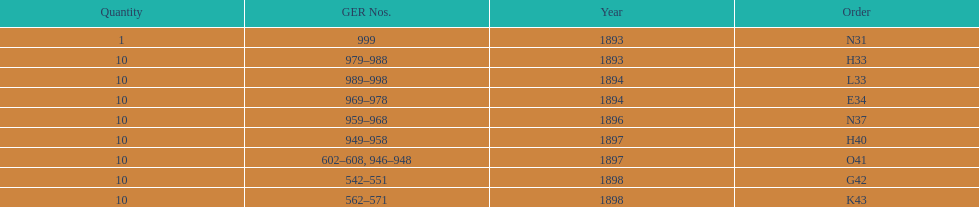Over how many years does the time span extend? 5 years. 